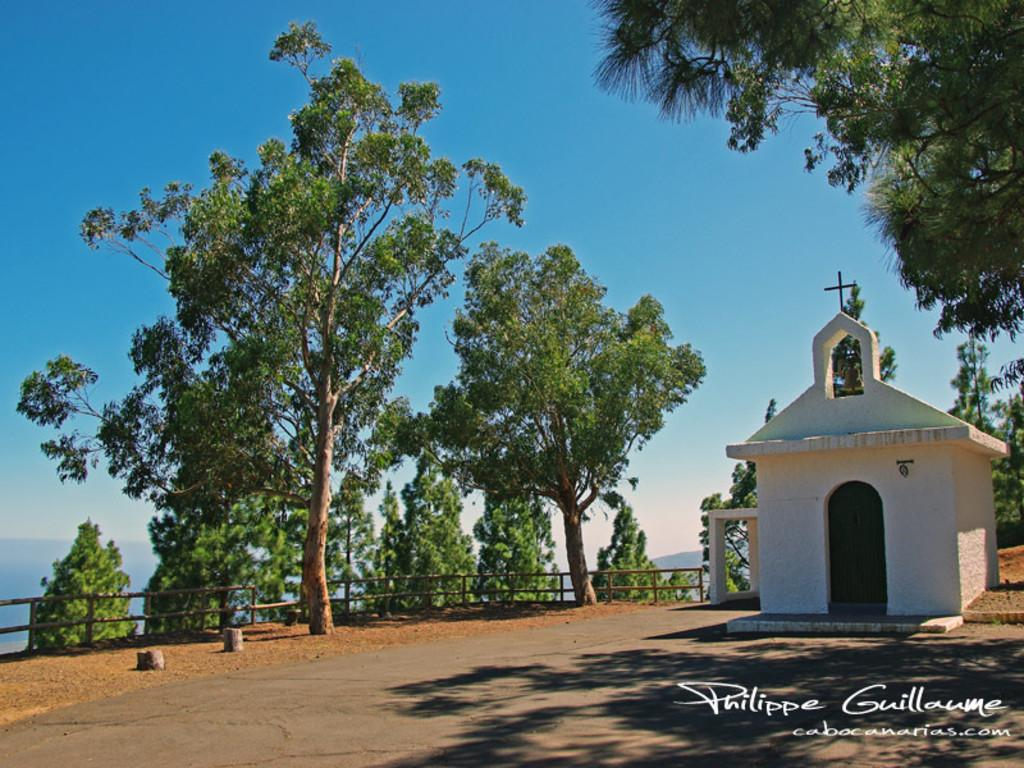What type of building is in the image? There is a church in the image. What other natural elements can be seen in the image? There are trees in the image. What architectural feature is present in the image? There is railing in the image. What is visible in the background of the image? The sky is visible in the image. What type of dress is hanging on the railing in the image? There is no dress present in the image; it features a church, trees, railing, and the sky. How does the sleet affect the church in the image? There is no mention of sleet in the image; it is a clear image featuring a church, trees, railing, and the sky. 